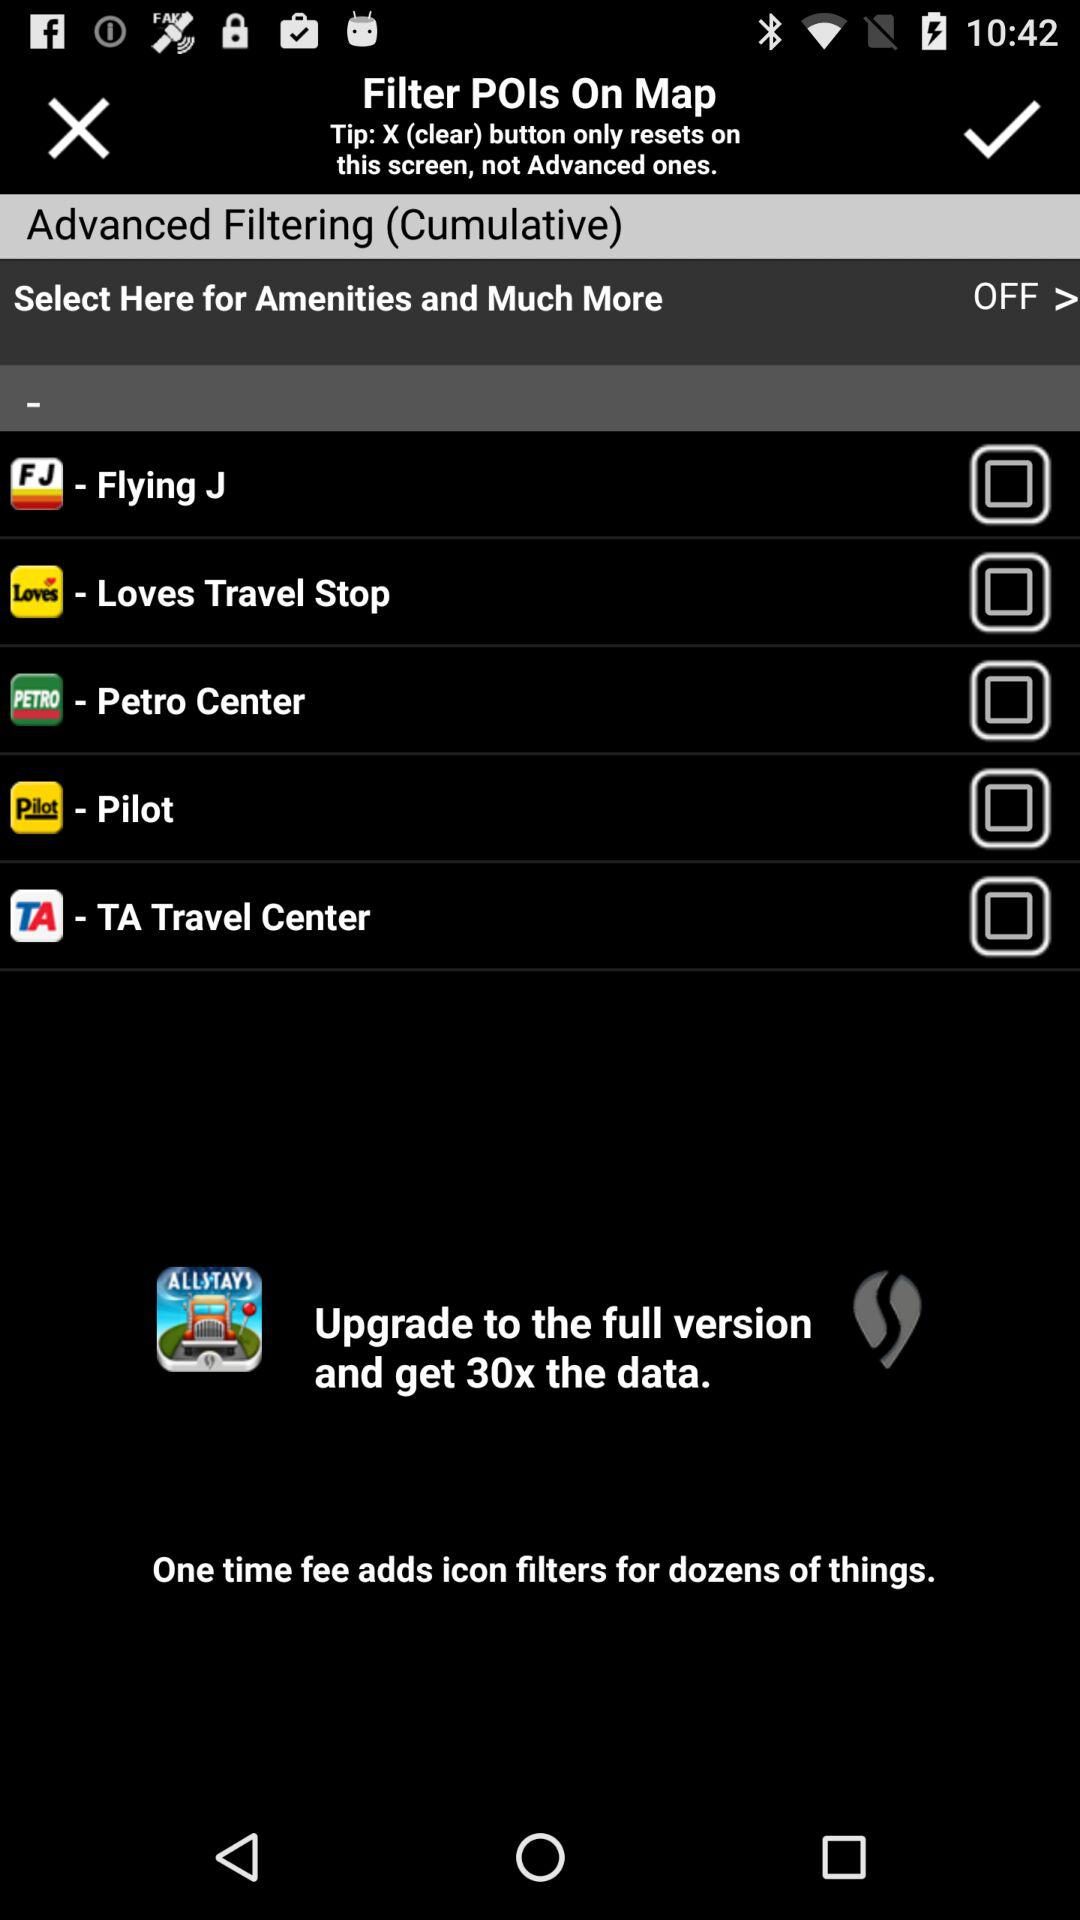What is the status of "Pilot"? The status of "Pilot" is "off". 